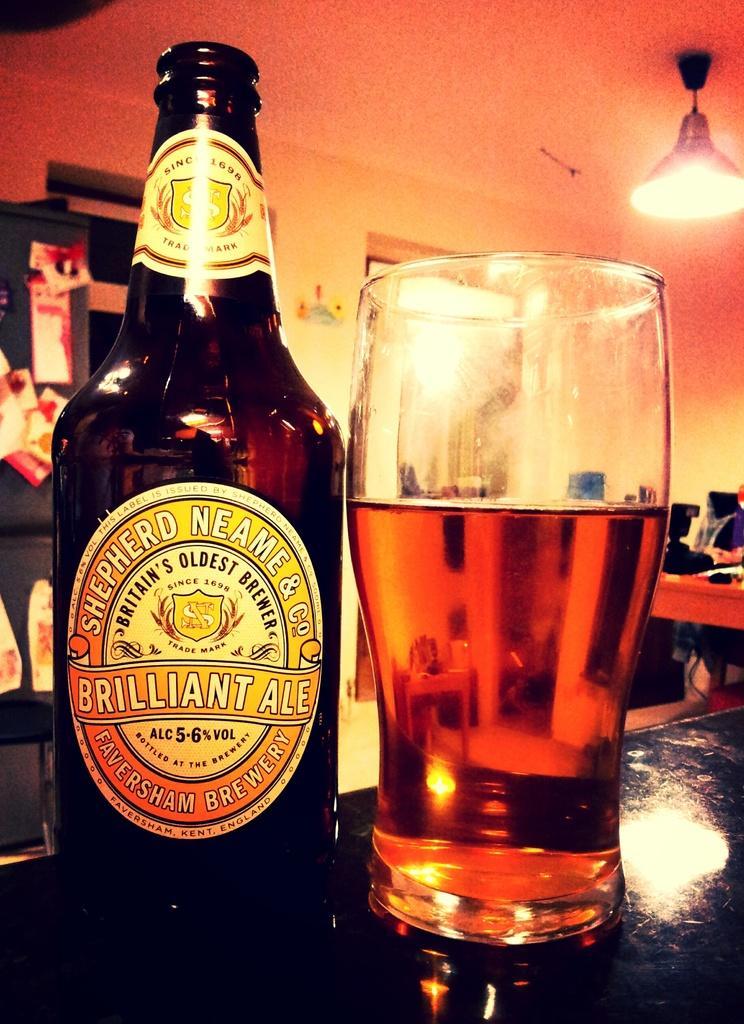Can you describe this image briefly? This picture is inside the room. There is a bottle and a glass. At the right side of the image there is a table, at the top there is a light. 